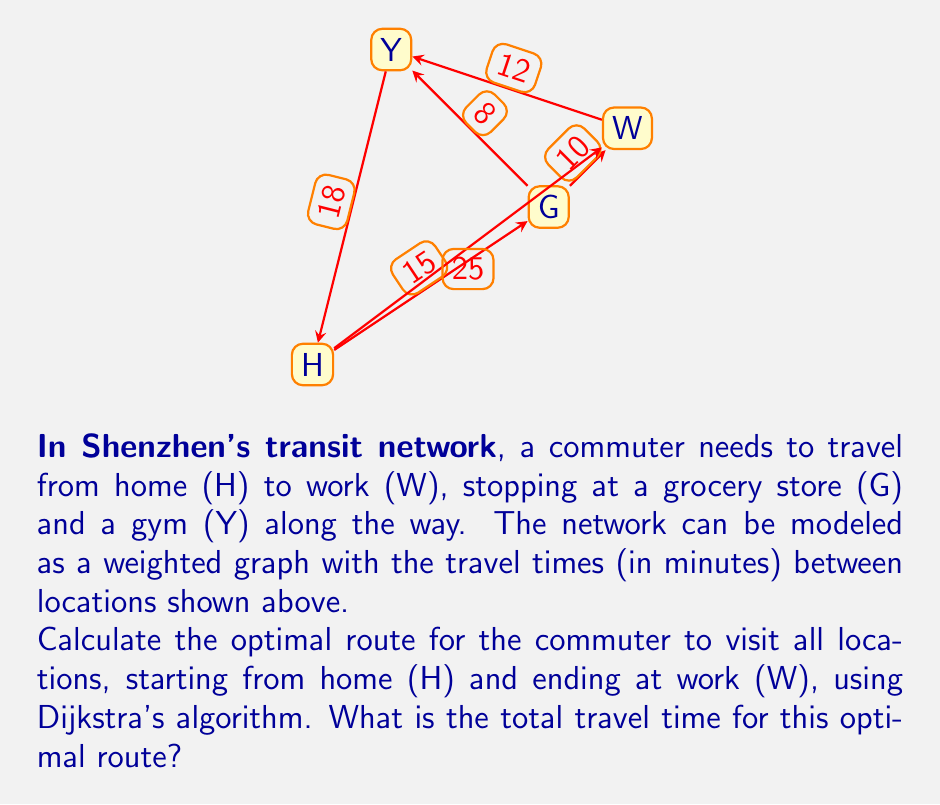Can you answer this question? To solve this problem using Dijkstra's algorithm, we need to find the shortest path that visits all nodes in the order H → G → Y → W. We'll break this down into steps:

1) First, find the shortest path from H to G:
   H → G (15 minutes)

2) Next, find the shortest path from G to Y:
   G → Y (8 minutes)

3) Finally, find the shortest path from Y to W:
   Y → W (12 minutes)

4) Sum up the travel times:
   $$\text{Total time} = 15 + 8 + 12 = 35 \text{ minutes}$$

Dijkstra's algorithm ensures that each segment of the journey (H→G, G→Y, Y→W) is optimized. The algorithm works as follows for each segment:

1) Initialize distances: Set distance to starting node as 0 and all others as infinity.
2) Mark all nodes as unvisited.
3) For the current node, consider all unvisited neighbors and calculate their tentative distances.
4) When all neighbors are considered, mark the current node as visited.
5) If the destination node has been marked visited, we're done.
6) Otherwise, select the unvisited node with the smallest tentative distance and repeat from step 3.

In this case, the graph is simple enough that the shortest paths are obvious, but for more complex networks, Dijkstra's algorithm would be essential.
Answer: 35 minutes 